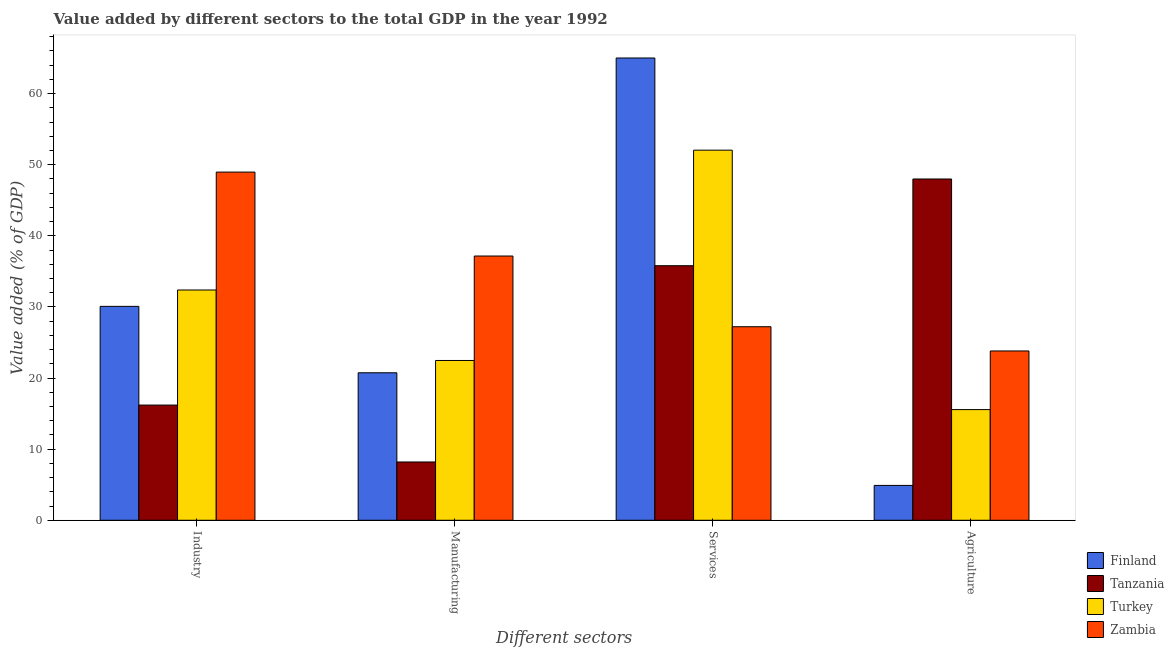Are the number of bars per tick equal to the number of legend labels?
Provide a short and direct response. Yes. Are the number of bars on each tick of the X-axis equal?
Your answer should be compact. Yes. How many bars are there on the 4th tick from the left?
Make the answer very short. 4. What is the label of the 2nd group of bars from the left?
Offer a very short reply. Manufacturing. What is the value added by manufacturing sector in Finland?
Give a very brief answer. 20.74. Across all countries, what is the maximum value added by services sector?
Provide a succinct answer. 65.02. Across all countries, what is the minimum value added by services sector?
Your answer should be very brief. 27.22. In which country was the value added by industrial sector maximum?
Your answer should be very brief. Zambia. What is the total value added by industrial sector in the graph?
Offer a very short reply. 127.64. What is the difference between the value added by agricultural sector in Finland and that in Tanzania?
Your response must be concise. -43.1. What is the difference between the value added by agricultural sector in Turkey and the value added by services sector in Tanzania?
Offer a very short reply. -20.24. What is the average value added by industrial sector per country?
Your answer should be very brief. 31.91. What is the difference between the value added by services sector and value added by industrial sector in Zambia?
Your response must be concise. -21.75. In how many countries, is the value added by agricultural sector greater than 46 %?
Provide a succinct answer. 1. What is the ratio of the value added by manufacturing sector in Tanzania to that in Finland?
Keep it short and to the point. 0.4. Is the difference between the value added by industrial sector in Finland and Zambia greater than the difference between the value added by manufacturing sector in Finland and Zambia?
Keep it short and to the point. No. What is the difference between the highest and the second highest value added by industrial sector?
Ensure brevity in your answer.  16.58. What is the difference between the highest and the lowest value added by agricultural sector?
Your response must be concise. 43.1. Is the sum of the value added by agricultural sector in Tanzania and Turkey greater than the maximum value added by manufacturing sector across all countries?
Keep it short and to the point. Yes. How many bars are there?
Your response must be concise. 16. Does the graph contain any zero values?
Your answer should be compact. No. Does the graph contain grids?
Make the answer very short. No. How many legend labels are there?
Make the answer very short. 4. How are the legend labels stacked?
Your response must be concise. Vertical. What is the title of the graph?
Offer a very short reply. Value added by different sectors to the total GDP in the year 1992. Does "Comoros" appear as one of the legend labels in the graph?
Your answer should be very brief. No. What is the label or title of the X-axis?
Provide a succinct answer. Different sectors. What is the label or title of the Y-axis?
Provide a short and direct response. Value added (% of GDP). What is the Value added (% of GDP) of Finland in Industry?
Make the answer very short. 30.08. What is the Value added (% of GDP) of Tanzania in Industry?
Offer a terse response. 16.2. What is the Value added (% of GDP) in Turkey in Industry?
Your answer should be very brief. 32.38. What is the Value added (% of GDP) in Zambia in Industry?
Ensure brevity in your answer.  48.97. What is the Value added (% of GDP) in Finland in Manufacturing?
Make the answer very short. 20.74. What is the Value added (% of GDP) of Tanzania in Manufacturing?
Give a very brief answer. 8.2. What is the Value added (% of GDP) of Turkey in Manufacturing?
Your response must be concise. 22.47. What is the Value added (% of GDP) in Zambia in Manufacturing?
Your answer should be very brief. 37.16. What is the Value added (% of GDP) of Finland in Services?
Ensure brevity in your answer.  65.02. What is the Value added (% of GDP) in Tanzania in Services?
Ensure brevity in your answer.  35.8. What is the Value added (% of GDP) in Turkey in Services?
Your response must be concise. 52.05. What is the Value added (% of GDP) of Zambia in Services?
Provide a short and direct response. 27.22. What is the Value added (% of GDP) of Finland in Agriculture?
Your answer should be compact. 4.9. What is the Value added (% of GDP) of Tanzania in Agriculture?
Your answer should be compact. 48. What is the Value added (% of GDP) in Turkey in Agriculture?
Provide a succinct answer. 15.56. What is the Value added (% of GDP) in Zambia in Agriculture?
Your response must be concise. 23.81. Across all Different sectors, what is the maximum Value added (% of GDP) in Finland?
Your answer should be compact. 65.02. Across all Different sectors, what is the maximum Value added (% of GDP) of Tanzania?
Your answer should be compact. 48. Across all Different sectors, what is the maximum Value added (% of GDP) in Turkey?
Give a very brief answer. 52.05. Across all Different sectors, what is the maximum Value added (% of GDP) of Zambia?
Your answer should be very brief. 48.97. Across all Different sectors, what is the minimum Value added (% of GDP) of Finland?
Provide a short and direct response. 4.9. Across all Different sectors, what is the minimum Value added (% of GDP) in Tanzania?
Provide a succinct answer. 8.2. Across all Different sectors, what is the minimum Value added (% of GDP) of Turkey?
Your response must be concise. 15.56. Across all Different sectors, what is the minimum Value added (% of GDP) in Zambia?
Keep it short and to the point. 23.81. What is the total Value added (% of GDP) of Finland in the graph?
Offer a terse response. 120.74. What is the total Value added (% of GDP) of Tanzania in the graph?
Make the answer very short. 108.2. What is the total Value added (% of GDP) in Turkey in the graph?
Ensure brevity in your answer.  122.47. What is the total Value added (% of GDP) in Zambia in the graph?
Make the answer very short. 137.16. What is the difference between the Value added (% of GDP) of Finland in Industry and that in Manufacturing?
Keep it short and to the point. 9.34. What is the difference between the Value added (% of GDP) in Tanzania in Industry and that in Manufacturing?
Offer a very short reply. 8. What is the difference between the Value added (% of GDP) of Turkey in Industry and that in Manufacturing?
Your answer should be compact. 9.91. What is the difference between the Value added (% of GDP) in Zambia in Industry and that in Manufacturing?
Offer a terse response. 11.8. What is the difference between the Value added (% of GDP) in Finland in Industry and that in Services?
Keep it short and to the point. -34.93. What is the difference between the Value added (% of GDP) in Tanzania in Industry and that in Services?
Give a very brief answer. -19.6. What is the difference between the Value added (% of GDP) of Turkey in Industry and that in Services?
Keep it short and to the point. -19.67. What is the difference between the Value added (% of GDP) of Zambia in Industry and that in Services?
Your answer should be compact. 21.75. What is the difference between the Value added (% of GDP) in Finland in Industry and that in Agriculture?
Make the answer very short. 25.18. What is the difference between the Value added (% of GDP) in Tanzania in Industry and that in Agriculture?
Offer a very short reply. -31.8. What is the difference between the Value added (% of GDP) in Turkey in Industry and that in Agriculture?
Your response must be concise. 16.82. What is the difference between the Value added (% of GDP) of Zambia in Industry and that in Agriculture?
Give a very brief answer. 25.16. What is the difference between the Value added (% of GDP) in Finland in Manufacturing and that in Services?
Keep it short and to the point. -44.27. What is the difference between the Value added (% of GDP) in Tanzania in Manufacturing and that in Services?
Offer a terse response. -27.6. What is the difference between the Value added (% of GDP) in Turkey in Manufacturing and that in Services?
Offer a terse response. -29.58. What is the difference between the Value added (% of GDP) in Zambia in Manufacturing and that in Services?
Provide a short and direct response. 9.94. What is the difference between the Value added (% of GDP) of Finland in Manufacturing and that in Agriculture?
Offer a terse response. 15.84. What is the difference between the Value added (% of GDP) in Tanzania in Manufacturing and that in Agriculture?
Offer a very short reply. -39.8. What is the difference between the Value added (% of GDP) of Turkey in Manufacturing and that in Agriculture?
Ensure brevity in your answer.  6.91. What is the difference between the Value added (% of GDP) of Zambia in Manufacturing and that in Agriculture?
Offer a very short reply. 13.35. What is the difference between the Value added (% of GDP) of Finland in Services and that in Agriculture?
Your answer should be very brief. 60.11. What is the difference between the Value added (% of GDP) in Tanzania in Services and that in Agriculture?
Keep it short and to the point. -12.2. What is the difference between the Value added (% of GDP) of Turkey in Services and that in Agriculture?
Ensure brevity in your answer.  36.49. What is the difference between the Value added (% of GDP) in Zambia in Services and that in Agriculture?
Your answer should be very brief. 3.41. What is the difference between the Value added (% of GDP) in Finland in Industry and the Value added (% of GDP) in Tanzania in Manufacturing?
Give a very brief answer. 21.89. What is the difference between the Value added (% of GDP) in Finland in Industry and the Value added (% of GDP) in Turkey in Manufacturing?
Ensure brevity in your answer.  7.61. What is the difference between the Value added (% of GDP) in Finland in Industry and the Value added (% of GDP) in Zambia in Manufacturing?
Make the answer very short. -7.08. What is the difference between the Value added (% of GDP) of Tanzania in Industry and the Value added (% of GDP) of Turkey in Manufacturing?
Offer a terse response. -6.27. What is the difference between the Value added (% of GDP) of Tanzania in Industry and the Value added (% of GDP) of Zambia in Manufacturing?
Provide a short and direct response. -20.96. What is the difference between the Value added (% of GDP) in Turkey in Industry and the Value added (% of GDP) in Zambia in Manufacturing?
Make the answer very short. -4.78. What is the difference between the Value added (% of GDP) in Finland in Industry and the Value added (% of GDP) in Tanzania in Services?
Ensure brevity in your answer.  -5.72. What is the difference between the Value added (% of GDP) in Finland in Industry and the Value added (% of GDP) in Turkey in Services?
Offer a very short reply. -21.97. What is the difference between the Value added (% of GDP) of Finland in Industry and the Value added (% of GDP) of Zambia in Services?
Keep it short and to the point. 2.86. What is the difference between the Value added (% of GDP) of Tanzania in Industry and the Value added (% of GDP) of Turkey in Services?
Offer a terse response. -35.85. What is the difference between the Value added (% of GDP) of Tanzania in Industry and the Value added (% of GDP) of Zambia in Services?
Ensure brevity in your answer.  -11.02. What is the difference between the Value added (% of GDP) in Turkey in Industry and the Value added (% of GDP) in Zambia in Services?
Keep it short and to the point. 5.17. What is the difference between the Value added (% of GDP) in Finland in Industry and the Value added (% of GDP) in Tanzania in Agriculture?
Give a very brief answer. -17.91. What is the difference between the Value added (% of GDP) in Finland in Industry and the Value added (% of GDP) in Turkey in Agriculture?
Offer a terse response. 14.52. What is the difference between the Value added (% of GDP) of Finland in Industry and the Value added (% of GDP) of Zambia in Agriculture?
Give a very brief answer. 6.27. What is the difference between the Value added (% of GDP) of Tanzania in Industry and the Value added (% of GDP) of Turkey in Agriculture?
Your response must be concise. 0.64. What is the difference between the Value added (% of GDP) of Tanzania in Industry and the Value added (% of GDP) of Zambia in Agriculture?
Provide a short and direct response. -7.61. What is the difference between the Value added (% of GDP) in Turkey in Industry and the Value added (% of GDP) in Zambia in Agriculture?
Your answer should be compact. 8.57. What is the difference between the Value added (% of GDP) in Finland in Manufacturing and the Value added (% of GDP) in Tanzania in Services?
Your response must be concise. -15.06. What is the difference between the Value added (% of GDP) in Finland in Manufacturing and the Value added (% of GDP) in Turkey in Services?
Give a very brief answer. -31.31. What is the difference between the Value added (% of GDP) of Finland in Manufacturing and the Value added (% of GDP) of Zambia in Services?
Offer a terse response. -6.48. What is the difference between the Value added (% of GDP) in Tanzania in Manufacturing and the Value added (% of GDP) in Turkey in Services?
Give a very brief answer. -43.85. What is the difference between the Value added (% of GDP) of Tanzania in Manufacturing and the Value added (% of GDP) of Zambia in Services?
Offer a terse response. -19.02. What is the difference between the Value added (% of GDP) of Turkey in Manufacturing and the Value added (% of GDP) of Zambia in Services?
Offer a very short reply. -4.75. What is the difference between the Value added (% of GDP) in Finland in Manufacturing and the Value added (% of GDP) in Tanzania in Agriculture?
Your answer should be very brief. -27.25. What is the difference between the Value added (% of GDP) of Finland in Manufacturing and the Value added (% of GDP) of Turkey in Agriculture?
Provide a short and direct response. 5.18. What is the difference between the Value added (% of GDP) in Finland in Manufacturing and the Value added (% of GDP) in Zambia in Agriculture?
Ensure brevity in your answer.  -3.07. What is the difference between the Value added (% of GDP) of Tanzania in Manufacturing and the Value added (% of GDP) of Turkey in Agriculture?
Offer a terse response. -7.37. What is the difference between the Value added (% of GDP) in Tanzania in Manufacturing and the Value added (% of GDP) in Zambia in Agriculture?
Ensure brevity in your answer.  -15.62. What is the difference between the Value added (% of GDP) of Turkey in Manufacturing and the Value added (% of GDP) of Zambia in Agriculture?
Provide a succinct answer. -1.34. What is the difference between the Value added (% of GDP) of Finland in Services and the Value added (% of GDP) of Tanzania in Agriculture?
Provide a succinct answer. 17.02. What is the difference between the Value added (% of GDP) of Finland in Services and the Value added (% of GDP) of Turkey in Agriculture?
Offer a terse response. 49.45. What is the difference between the Value added (% of GDP) of Finland in Services and the Value added (% of GDP) of Zambia in Agriculture?
Provide a short and direct response. 41.2. What is the difference between the Value added (% of GDP) of Tanzania in Services and the Value added (% of GDP) of Turkey in Agriculture?
Ensure brevity in your answer.  20.24. What is the difference between the Value added (% of GDP) in Tanzania in Services and the Value added (% of GDP) in Zambia in Agriculture?
Provide a short and direct response. 11.99. What is the difference between the Value added (% of GDP) in Turkey in Services and the Value added (% of GDP) in Zambia in Agriculture?
Provide a succinct answer. 28.24. What is the average Value added (% of GDP) in Finland per Different sectors?
Ensure brevity in your answer.  30.19. What is the average Value added (% of GDP) in Tanzania per Different sectors?
Provide a succinct answer. 27.05. What is the average Value added (% of GDP) in Turkey per Different sectors?
Offer a terse response. 30.62. What is the average Value added (% of GDP) in Zambia per Different sectors?
Offer a very short reply. 34.29. What is the difference between the Value added (% of GDP) of Finland and Value added (% of GDP) of Tanzania in Industry?
Your answer should be very brief. 13.88. What is the difference between the Value added (% of GDP) of Finland and Value added (% of GDP) of Turkey in Industry?
Provide a succinct answer. -2.3. What is the difference between the Value added (% of GDP) in Finland and Value added (% of GDP) in Zambia in Industry?
Your answer should be very brief. -18.88. What is the difference between the Value added (% of GDP) of Tanzania and Value added (% of GDP) of Turkey in Industry?
Your answer should be compact. -16.18. What is the difference between the Value added (% of GDP) in Tanzania and Value added (% of GDP) in Zambia in Industry?
Provide a succinct answer. -32.77. What is the difference between the Value added (% of GDP) of Turkey and Value added (% of GDP) of Zambia in Industry?
Your answer should be compact. -16.58. What is the difference between the Value added (% of GDP) in Finland and Value added (% of GDP) in Tanzania in Manufacturing?
Your answer should be very brief. 12.55. What is the difference between the Value added (% of GDP) in Finland and Value added (% of GDP) in Turkey in Manufacturing?
Make the answer very short. -1.73. What is the difference between the Value added (% of GDP) of Finland and Value added (% of GDP) of Zambia in Manufacturing?
Keep it short and to the point. -16.42. What is the difference between the Value added (% of GDP) in Tanzania and Value added (% of GDP) in Turkey in Manufacturing?
Provide a succinct answer. -14.28. What is the difference between the Value added (% of GDP) in Tanzania and Value added (% of GDP) in Zambia in Manufacturing?
Provide a succinct answer. -28.97. What is the difference between the Value added (% of GDP) in Turkey and Value added (% of GDP) in Zambia in Manufacturing?
Ensure brevity in your answer.  -14.69. What is the difference between the Value added (% of GDP) of Finland and Value added (% of GDP) of Tanzania in Services?
Provide a short and direct response. 29.21. What is the difference between the Value added (% of GDP) of Finland and Value added (% of GDP) of Turkey in Services?
Ensure brevity in your answer.  12.96. What is the difference between the Value added (% of GDP) in Finland and Value added (% of GDP) in Zambia in Services?
Give a very brief answer. 37.8. What is the difference between the Value added (% of GDP) of Tanzania and Value added (% of GDP) of Turkey in Services?
Keep it short and to the point. -16.25. What is the difference between the Value added (% of GDP) in Tanzania and Value added (% of GDP) in Zambia in Services?
Provide a short and direct response. 8.58. What is the difference between the Value added (% of GDP) in Turkey and Value added (% of GDP) in Zambia in Services?
Provide a short and direct response. 24.83. What is the difference between the Value added (% of GDP) in Finland and Value added (% of GDP) in Tanzania in Agriculture?
Give a very brief answer. -43.1. What is the difference between the Value added (% of GDP) of Finland and Value added (% of GDP) of Turkey in Agriculture?
Make the answer very short. -10.66. What is the difference between the Value added (% of GDP) in Finland and Value added (% of GDP) in Zambia in Agriculture?
Your response must be concise. -18.91. What is the difference between the Value added (% of GDP) in Tanzania and Value added (% of GDP) in Turkey in Agriculture?
Offer a very short reply. 32.43. What is the difference between the Value added (% of GDP) in Tanzania and Value added (% of GDP) in Zambia in Agriculture?
Your answer should be very brief. 24.18. What is the difference between the Value added (% of GDP) of Turkey and Value added (% of GDP) of Zambia in Agriculture?
Offer a very short reply. -8.25. What is the ratio of the Value added (% of GDP) in Finland in Industry to that in Manufacturing?
Your answer should be very brief. 1.45. What is the ratio of the Value added (% of GDP) of Tanzania in Industry to that in Manufacturing?
Provide a succinct answer. 1.98. What is the ratio of the Value added (% of GDP) of Turkey in Industry to that in Manufacturing?
Offer a very short reply. 1.44. What is the ratio of the Value added (% of GDP) of Zambia in Industry to that in Manufacturing?
Provide a succinct answer. 1.32. What is the ratio of the Value added (% of GDP) in Finland in Industry to that in Services?
Keep it short and to the point. 0.46. What is the ratio of the Value added (% of GDP) in Tanzania in Industry to that in Services?
Provide a succinct answer. 0.45. What is the ratio of the Value added (% of GDP) of Turkey in Industry to that in Services?
Keep it short and to the point. 0.62. What is the ratio of the Value added (% of GDP) of Zambia in Industry to that in Services?
Give a very brief answer. 1.8. What is the ratio of the Value added (% of GDP) of Finland in Industry to that in Agriculture?
Provide a short and direct response. 6.14. What is the ratio of the Value added (% of GDP) of Tanzania in Industry to that in Agriculture?
Keep it short and to the point. 0.34. What is the ratio of the Value added (% of GDP) in Turkey in Industry to that in Agriculture?
Provide a succinct answer. 2.08. What is the ratio of the Value added (% of GDP) in Zambia in Industry to that in Agriculture?
Provide a succinct answer. 2.06. What is the ratio of the Value added (% of GDP) of Finland in Manufacturing to that in Services?
Keep it short and to the point. 0.32. What is the ratio of the Value added (% of GDP) of Tanzania in Manufacturing to that in Services?
Provide a short and direct response. 0.23. What is the ratio of the Value added (% of GDP) in Turkey in Manufacturing to that in Services?
Your answer should be very brief. 0.43. What is the ratio of the Value added (% of GDP) in Zambia in Manufacturing to that in Services?
Ensure brevity in your answer.  1.37. What is the ratio of the Value added (% of GDP) of Finland in Manufacturing to that in Agriculture?
Ensure brevity in your answer.  4.23. What is the ratio of the Value added (% of GDP) in Tanzania in Manufacturing to that in Agriculture?
Ensure brevity in your answer.  0.17. What is the ratio of the Value added (% of GDP) in Turkey in Manufacturing to that in Agriculture?
Keep it short and to the point. 1.44. What is the ratio of the Value added (% of GDP) of Zambia in Manufacturing to that in Agriculture?
Your response must be concise. 1.56. What is the ratio of the Value added (% of GDP) of Finland in Services to that in Agriculture?
Offer a terse response. 13.26. What is the ratio of the Value added (% of GDP) of Tanzania in Services to that in Agriculture?
Ensure brevity in your answer.  0.75. What is the ratio of the Value added (% of GDP) of Turkey in Services to that in Agriculture?
Your response must be concise. 3.34. What is the ratio of the Value added (% of GDP) of Zambia in Services to that in Agriculture?
Your answer should be very brief. 1.14. What is the difference between the highest and the second highest Value added (% of GDP) in Finland?
Ensure brevity in your answer.  34.93. What is the difference between the highest and the second highest Value added (% of GDP) in Tanzania?
Provide a succinct answer. 12.2. What is the difference between the highest and the second highest Value added (% of GDP) in Turkey?
Keep it short and to the point. 19.67. What is the difference between the highest and the second highest Value added (% of GDP) in Zambia?
Your answer should be compact. 11.8. What is the difference between the highest and the lowest Value added (% of GDP) in Finland?
Ensure brevity in your answer.  60.11. What is the difference between the highest and the lowest Value added (% of GDP) in Tanzania?
Offer a very short reply. 39.8. What is the difference between the highest and the lowest Value added (% of GDP) of Turkey?
Ensure brevity in your answer.  36.49. What is the difference between the highest and the lowest Value added (% of GDP) in Zambia?
Keep it short and to the point. 25.16. 